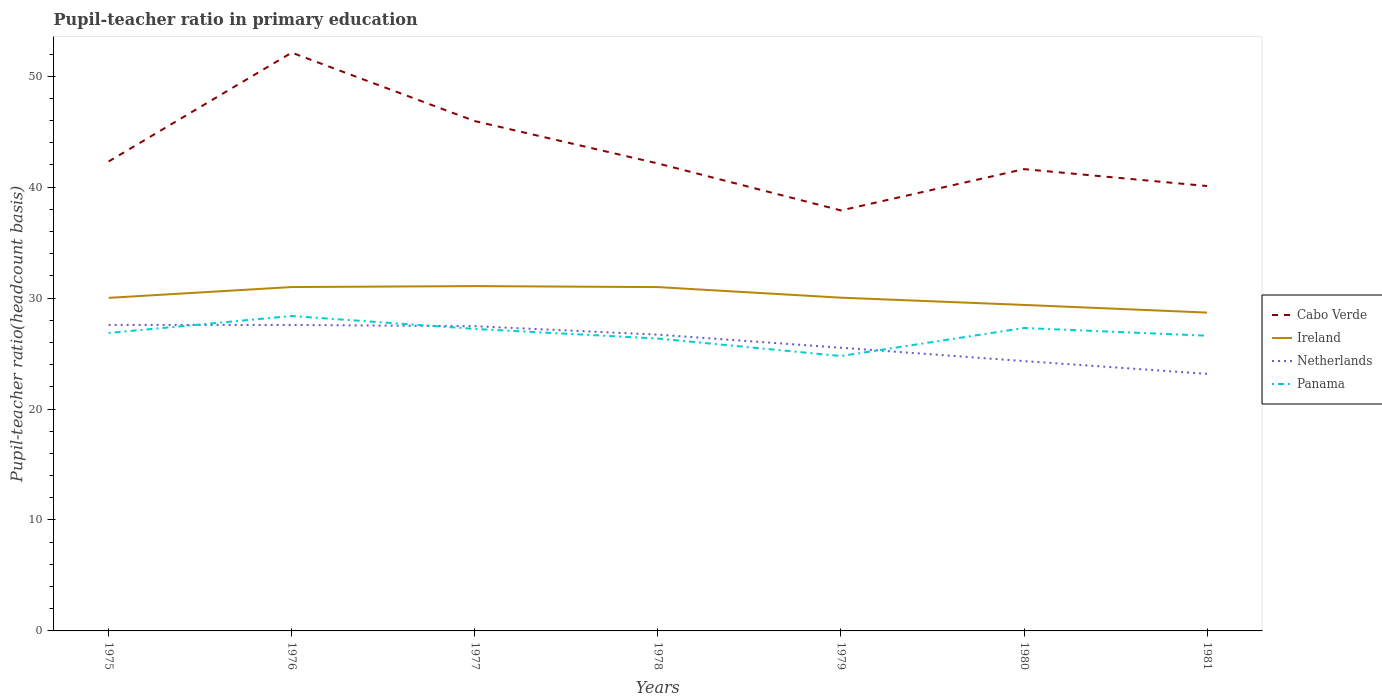Does the line corresponding to Ireland intersect with the line corresponding to Panama?
Keep it short and to the point. No. Across all years, what is the maximum pupil-teacher ratio in primary education in Netherlands?
Provide a short and direct response. 23.17. In which year was the pupil-teacher ratio in primary education in Ireland maximum?
Offer a terse response. 1981. What is the total pupil-teacher ratio in primary education in Ireland in the graph?
Make the answer very short. 0.95. What is the difference between the highest and the second highest pupil-teacher ratio in primary education in Cabo Verde?
Give a very brief answer. 14.22. What is the difference between the highest and the lowest pupil-teacher ratio in primary education in Ireland?
Provide a succinct answer. 3. Is the pupil-teacher ratio in primary education in Ireland strictly greater than the pupil-teacher ratio in primary education in Panama over the years?
Your answer should be very brief. No. How many lines are there?
Your answer should be very brief. 4. How many years are there in the graph?
Give a very brief answer. 7. What is the difference between two consecutive major ticks on the Y-axis?
Give a very brief answer. 10. Are the values on the major ticks of Y-axis written in scientific E-notation?
Provide a short and direct response. No. Does the graph contain grids?
Provide a short and direct response. No. Where does the legend appear in the graph?
Offer a very short reply. Center right. What is the title of the graph?
Provide a short and direct response. Pupil-teacher ratio in primary education. Does "Middle income" appear as one of the legend labels in the graph?
Your answer should be very brief. No. What is the label or title of the X-axis?
Offer a very short reply. Years. What is the label or title of the Y-axis?
Keep it short and to the point. Pupil-teacher ratio(headcount basis). What is the Pupil-teacher ratio(headcount basis) of Cabo Verde in 1975?
Ensure brevity in your answer.  42.31. What is the Pupil-teacher ratio(headcount basis) in Ireland in 1975?
Offer a very short reply. 30.02. What is the Pupil-teacher ratio(headcount basis) in Netherlands in 1975?
Your answer should be very brief. 27.58. What is the Pupil-teacher ratio(headcount basis) in Panama in 1975?
Your response must be concise. 26.86. What is the Pupil-teacher ratio(headcount basis) in Cabo Verde in 1976?
Your response must be concise. 52.13. What is the Pupil-teacher ratio(headcount basis) of Ireland in 1976?
Your answer should be very brief. 31. What is the Pupil-teacher ratio(headcount basis) in Netherlands in 1976?
Make the answer very short. 27.58. What is the Pupil-teacher ratio(headcount basis) in Panama in 1976?
Give a very brief answer. 28.39. What is the Pupil-teacher ratio(headcount basis) of Cabo Verde in 1977?
Give a very brief answer. 45.96. What is the Pupil-teacher ratio(headcount basis) in Ireland in 1977?
Offer a very short reply. 31.08. What is the Pupil-teacher ratio(headcount basis) of Netherlands in 1977?
Provide a short and direct response. 27.47. What is the Pupil-teacher ratio(headcount basis) in Panama in 1977?
Make the answer very short. 27.22. What is the Pupil-teacher ratio(headcount basis) in Cabo Verde in 1978?
Ensure brevity in your answer.  42.14. What is the Pupil-teacher ratio(headcount basis) in Ireland in 1978?
Ensure brevity in your answer.  30.99. What is the Pupil-teacher ratio(headcount basis) in Netherlands in 1978?
Give a very brief answer. 26.71. What is the Pupil-teacher ratio(headcount basis) in Panama in 1978?
Provide a short and direct response. 26.35. What is the Pupil-teacher ratio(headcount basis) in Cabo Verde in 1979?
Make the answer very short. 37.9. What is the Pupil-teacher ratio(headcount basis) of Ireland in 1979?
Keep it short and to the point. 30.04. What is the Pupil-teacher ratio(headcount basis) in Netherlands in 1979?
Your answer should be compact. 25.53. What is the Pupil-teacher ratio(headcount basis) of Panama in 1979?
Your answer should be compact. 24.78. What is the Pupil-teacher ratio(headcount basis) of Cabo Verde in 1980?
Make the answer very short. 41.63. What is the Pupil-teacher ratio(headcount basis) in Ireland in 1980?
Make the answer very short. 29.39. What is the Pupil-teacher ratio(headcount basis) in Netherlands in 1980?
Make the answer very short. 24.32. What is the Pupil-teacher ratio(headcount basis) in Panama in 1980?
Offer a terse response. 27.31. What is the Pupil-teacher ratio(headcount basis) in Cabo Verde in 1981?
Make the answer very short. 40.1. What is the Pupil-teacher ratio(headcount basis) in Ireland in 1981?
Ensure brevity in your answer.  28.7. What is the Pupil-teacher ratio(headcount basis) of Netherlands in 1981?
Give a very brief answer. 23.17. What is the Pupil-teacher ratio(headcount basis) of Panama in 1981?
Provide a succinct answer. 26.61. Across all years, what is the maximum Pupil-teacher ratio(headcount basis) of Cabo Verde?
Ensure brevity in your answer.  52.13. Across all years, what is the maximum Pupil-teacher ratio(headcount basis) of Ireland?
Your answer should be very brief. 31.08. Across all years, what is the maximum Pupil-teacher ratio(headcount basis) of Netherlands?
Your answer should be compact. 27.58. Across all years, what is the maximum Pupil-teacher ratio(headcount basis) in Panama?
Give a very brief answer. 28.39. Across all years, what is the minimum Pupil-teacher ratio(headcount basis) in Cabo Verde?
Provide a short and direct response. 37.9. Across all years, what is the minimum Pupil-teacher ratio(headcount basis) in Ireland?
Provide a succinct answer. 28.7. Across all years, what is the minimum Pupil-teacher ratio(headcount basis) of Netherlands?
Ensure brevity in your answer.  23.17. Across all years, what is the minimum Pupil-teacher ratio(headcount basis) in Panama?
Give a very brief answer. 24.78. What is the total Pupil-teacher ratio(headcount basis) in Cabo Verde in the graph?
Offer a terse response. 302.17. What is the total Pupil-teacher ratio(headcount basis) of Ireland in the graph?
Provide a short and direct response. 211.22. What is the total Pupil-teacher ratio(headcount basis) in Netherlands in the graph?
Offer a very short reply. 182.36. What is the total Pupil-teacher ratio(headcount basis) of Panama in the graph?
Your answer should be very brief. 187.52. What is the difference between the Pupil-teacher ratio(headcount basis) in Cabo Verde in 1975 and that in 1976?
Ensure brevity in your answer.  -9.81. What is the difference between the Pupil-teacher ratio(headcount basis) of Ireland in 1975 and that in 1976?
Your response must be concise. -0.97. What is the difference between the Pupil-teacher ratio(headcount basis) of Netherlands in 1975 and that in 1976?
Your response must be concise. 0. What is the difference between the Pupil-teacher ratio(headcount basis) of Panama in 1975 and that in 1976?
Provide a succinct answer. -1.53. What is the difference between the Pupil-teacher ratio(headcount basis) in Cabo Verde in 1975 and that in 1977?
Your response must be concise. -3.64. What is the difference between the Pupil-teacher ratio(headcount basis) in Ireland in 1975 and that in 1977?
Offer a terse response. -1.06. What is the difference between the Pupil-teacher ratio(headcount basis) of Netherlands in 1975 and that in 1977?
Your answer should be compact. 0.11. What is the difference between the Pupil-teacher ratio(headcount basis) in Panama in 1975 and that in 1977?
Offer a terse response. -0.36. What is the difference between the Pupil-teacher ratio(headcount basis) of Cabo Verde in 1975 and that in 1978?
Ensure brevity in your answer.  0.18. What is the difference between the Pupil-teacher ratio(headcount basis) in Ireland in 1975 and that in 1978?
Keep it short and to the point. -0.97. What is the difference between the Pupil-teacher ratio(headcount basis) in Netherlands in 1975 and that in 1978?
Offer a terse response. 0.88. What is the difference between the Pupil-teacher ratio(headcount basis) in Panama in 1975 and that in 1978?
Keep it short and to the point. 0.5. What is the difference between the Pupil-teacher ratio(headcount basis) in Cabo Verde in 1975 and that in 1979?
Provide a short and direct response. 4.41. What is the difference between the Pupil-teacher ratio(headcount basis) of Ireland in 1975 and that in 1979?
Offer a very short reply. -0.02. What is the difference between the Pupil-teacher ratio(headcount basis) in Netherlands in 1975 and that in 1979?
Offer a terse response. 2.05. What is the difference between the Pupil-teacher ratio(headcount basis) of Panama in 1975 and that in 1979?
Ensure brevity in your answer.  2.08. What is the difference between the Pupil-teacher ratio(headcount basis) of Cabo Verde in 1975 and that in 1980?
Ensure brevity in your answer.  0.69. What is the difference between the Pupil-teacher ratio(headcount basis) of Ireland in 1975 and that in 1980?
Give a very brief answer. 0.64. What is the difference between the Pupil-teacher ratio(headcount basis) of Netherlands in 1975 and that in 1980?
Your response must be concise. 3.26. What is the difference between the Pupil-teacher ratio(headcount basis) in Panama in 1975 and that in 1980?
Make the answer very short. -0.45. What is the difference between the Pupil-teacher ratio(headcount basis) in Cabo Verde in 1975 and that in 1981?
Offer a terse response. 2.21. What is the difference between the Pupil-teacher ratio(headcount basis) of Ireland in 1975 and that in 1981?
Your response must be concise. 1.33. What is the difference between the Pupil-teacher ratio(headcount basis) in Netherlands in 1975 and that in 1981?
Your answer should be very brief. 4.41. What is the difference between the Pupil-teacher ratio(headcount basis) of Panama in 1975 and that in 1981?
Keep it short and to the point. 0.25. What is the difference between the Pupil-teacher ratio(headcount basis) in Cabo Verde in 1976 and that in 1977?
Provide a succinct answer. 6.17. What is the difference between the Pupil-teacher ratio(headcount basis) in Ireland in 1976 and that in 1977?
Provide a short and direct response. -0.09. What is the difference between the Pupil-teacher ratio(headcount basis) of Netherlands in 1976 and that in 1977?
Ensure brevity in your answer.  0.11. What is the difference between the Pupil-teacher ratio(headcount basis) in Panama in 1976 and that in 1977?
Make the answer very short. 1.17. What is the difference between the Pupil-teacher ratio(headcount basis) of Cabo Verde in 1976 and that in 1978?
Your answer should be very brief. 9.99. What is the difference between the Pupil-teacher ratio(headcount basis) in Ireland in 1976 and that in 1978?
Make the answer very short. 0. What is the difference between the Pupil-teacher ratio(headcount basis) in Netherlands in 1976 and that in 1978?
Offer a terse response. 0.87. What is the difference between the Pupil-teacher ratio(headcount basis) in Panama in 1976 and that in 1978?
Ensure brevity in your answer.  2.03. What is the difference between the Pupil-teacher ratio(headcount basis) of Cabo Verde in 1976 and that in 1979?
Ensure brevity in your answer.  14.22. What is the difference between the Pupil-teacher ratio(headcount basis) in Ireland in 1976 and that in 1979?
Make the answer very short. 0.96. What is the difference between the Pupil-teacher ratio(headcount basis) of Netherlands in 1976 and that in 1979?
Keep it short and to the point. 2.05. What is the difference between the Pupil-teacher ratio(headcount basis) in Panama in 1976 and that in 1979?
Provide a succinct answer. 3.61. What is the difference between the Pupil-teacher ratio(headcount basis) of Cabo Verde in 1976 and that in 1980?
Provide a short and direct response. 10.5. What is the difference between the Pupil-teacher ratio(headcount basis) of Ireland in 1976 and that in 1980?
Your answer should be compact. 1.61. What is the difference between the Pupil-teacher ratio(headcount basis) of Netherlands in 1976 and that in 1980?
Your answer should be compact. 3.26. What is the difference between the Pupil-teacher ratio(headcount basis) of Panama in 1976 and that in 1980?
Your answer should be very brief. 1.08. What is the difference between the Pupil-teacher ratio(headcount basis) in Cabo Verde in 1976 and that in 1981?
Offer a terse response. 12.02. What is the difference between the Pupil-teacher ratio(headcount basis) in Ireland in 1976 and that in 1981?
Your response must be concise. 2.3. What is the difference between the Pupil-teacher ratio(headcount basis) of Netherlands in 1976 and that in 1981?
Provide a succinct answer. 4.41. What is the difference between the Pupil-teacher ratio(headcount basis) of Panama in 1976 and that in 1981?
Offer a terse response. 1.78. What is the difference between the Pupil-teacher ratio(headcount basis) of Cabo Verde in 1977 and that in 1978?
Offer a terse response. 3.82. What is the difference between the Pupil-teacher ratio(headcount basis) of Ireland in 1977 and that in 1978?
Provide a succinct answer. 0.09. What is the difference between the Pupil-teacher ratio(headcount basis) in Netherlands in 1977 and that in 1978?
Provide a short and direct response. 0.76. What is the difference between the Pupil-teacher ratio(headcount basis) in Panama in 1977 and that in 1978?
Provide a short and direct response. 0.87. What is the difference between the Pupil-teacher ratio(headcount basis) of Cabo Verde in 1977 and that in 1979?
Provide a succinct answer. 8.05. What is the difference between the Pupil-teacher ratio(headcount basis) in Ireland in 1977 and that in 1979?
Provide a succinct answer. 1.04. What is the difference between the Pupil-teacher ratio(headcount basis) of Netherlands in 1977 and that in 1979?
Keep it short and to the point. 1.94. What is the difference between the Pupil-teacher ratio(headcount basis) of Panama in 1977 and that in 1979?
Offer a terse response. 2.44. What is the difference between the Pupil-teacher ratio(headcount basis) of Cabo Verde in 1977 and that in 1980?
Provide a short and direct response. 4.33. What is the difference between the Pupil-teacher ratio(headcount basis) of Ireland in 1977 and that in 1980?
Make the answer very short. 1.7. What is the difference between the Pupil-teacher ratio(headcount basis) in Netherlands in 1977 and that in 1980?
Make the answer very short. 3.15. What is the difference between the Pupil-teacher ratio(headcount basis) of Panama in 1977 and that in 1980?
Keep it short and to the point. -0.08. What is the difference between the Pupil-teacher ratio(headcount basis) in Cabo Verde in 1977 and that in 1981?
Your answer should be compact. 5.85. What is the difference between the Pupil-teacher ratio(headcount basis) of Ireland in 1977 and that in 1981?
Your response must be concise. 2.39. What is the difference between the Pupil-teacher ratio(headcount basis) of Netherlands in 1977 and that in 1981?
Make the answer very short. 4.29. What is the difference between the Pupil-teacher ratio(headcount basis) in Panama in 1977 and that in 1981?
Offer a terse response. 0.61. What is the difference between the Pupil-teacher ratio(headcount basis) of Cabo Verde in 1978 and that in 1979?
Keep it short and to the point. 4.23. What is the difference between the Pupil-teacher ratio(headcount basis) in Ireland in 1978 and that in 1979?
Provide a short and direct response. 0.95. What is the difference between the Pupil-teacher ratio(headcount basis) in Netherlands in 1978 and that in 1979?
Your response must be concise. 1.18. What is the difference between the Pupil-teacher ratio(headcount basis) of Panama in 1978 and that in 1979?
Your answer should be compact. 1.58. What is the difference between the Pupil-teacher ratio(headcount basis) in Cabo Verde in 1978 and that in 1980?
Give a very brief answer. 0.51. What is the difference between the Pupil-teacher ratio(headcount basis) in Ireland in 1978 and that in 1980?
Offer a terse response. 1.61. What is the difference between the Pupil-teacher ratio(headcount basis) of Netherlands in 1978 and that in 1980?
Your answer should be compact. 2.38. What is the difference between the Pupil-teacher ratio(headcount basis) in Panama in 1978 and that in 1980?
Your response must be concise. -0.95. What is the difference between the Pupil-teacher ratio(headcount basis) in Cabo Verde in 1978 and that in 1981?
Give a very brief answer. 2.04. What is the difference between the Pupil-teacher ratio(headcount basis) in Ireland in 1978 and that in 1981?
Offer a very short reply. 2.3. What is the difference between the Pupil-teacher ratio(headcount basis) in Netherlands in 1978 and that in 1981?
Provide a succinct answer. 3.53. What is the difference between the Pupil-teacher ratio(headcount basis) of Panama in 1978 and that in 1981?
Provide a succinct answer. -0.26. What is the difference between the Pupil-teacher ratio(headcount basis) of Cabo Verde in 1979 and that in 1980?
Offer a terse response. -3.72. What is the difference between the Pupil-teacher ratio(headcount basis) in Ireland in 1979 and that in 1980?
Keep it short and to the point. 0.65. What is the difference between the Pupil-teacher ratio(headcount basis) of Netherlands in 1979 and that in 1980?
Ensure brevity in your answer.  1.2. What is the difference between the Pupil-teacher ratio(headcount basis) of Panama in 1979 and that in 1980?
Offer a terse response. -2.53. What is the difference between the Pupil-teacher ratio(headcount basis) in Cabo Verde in 1979 and that in 1981?
Provide a short and direct response. -2.2. What is the difference between the Pupil-teacher ratio(headcount basis) in Ireland in 1979 and that in 1981?
Offer a very short reply. 1.34. What is the difference between the Pupil-teacher ratio(headcount basis) of Netherlands in 1979 and that in 1981?
Your answer should be compact. 2.35. What is the difference between the Pupil-teacher ratio(headcount basis) in Panama in 1979 and that in 1981?
Your response must be concise. -1.83. What is the difference between the Pupil-teacher ratio(headcount basis) of Cabo Verde in 1980 and that in 1981?
Offer a terse response. 1.52. What is the difference between the Pupil-teacher ratio(headcount basis) of Ireland in 1980 and that in 1981?
Offer a very short reply. 0.69. What is the difference between the Pupil-teacher ratio(headcount basis) of Netherlands in 1980 and that in 1981?
Your answer should be very brief. 1.15. What is the difference between the Pupil-teacher ratio(headcount basis) in Panama in 1980 and that in 1981?
Your answer should be compact. 0.69. What is the difference between the Pupil-teacher ratio(headcount basis) in Cabo Verde in 1975 and the Pupil-teacher ratio(headcount basis) in Ireland in 1976?
Offer a terse response. 11.32. What is the difference between the Pupil-teacher ratio(headcount basis) in Cabo Verde in 1975 and the Pupil-teacher ratio(headcount basis) in Netherlands in 1976?
Keep it short and to the point. 14.73. What is the difference between the Pupil-teacher ratio(headcount basis) of Cabo Verde in 1975 and the Pupil-teacher ratio(headcount basis) of Panama in 1976?
Your answer should be very brief. 13.93. What is the difference between the Pupil-teacher ratio(headcount basis) in Ireland in 1975 and the Pupil-teacher ratio(headcount basis) in Netherlands in 1976?
Your response must be concise. 2.44. What is the difference between the Pupil-teacher ratio(headcount basis) of Ireland in 1975 and the Pupil-teacher ratio(headcount basis) of Panama in 1976?
Ensure brevity in your answer.  1.64. What is the difference between the Pupil-teacher ratio(headcount basis) in Netherlands in 1975 and the Pupil-teacher ratio(headcount basis) in Panama in 1976?
Provide a short and direct response. -0.8. What is the difference between the Pupil-teacher ratio(headcount basis) of Cabo Verde in 1975 and the Pupil-teacher ratio(headcount basis) of Ireland in 1977?
Offer a very short reply. 11.23. What is the difference between the Pupil-teacher ratio(headcount basis) of Cabo Verde in 1975 and the Pupil-teacher ratio(headcount basis) of Netherlands in 1977?
Make the answer very short. 14.85. What is the difference between the Pupil-teacher ratio(headcount basis) of Cabo Verde in 1975 and the Pupil-teacher ratio(headcount basis) of Panama in 1977?
Keep it short and to the point. 15.09. What is the difference between the Pupil-teacher ratio(headcount basis) in Ireland in 1975 and the Pupil-teacher ratio(headcount basis) in Netherlands in 1977?
Provide a succinct answer. 2.55. What is the difference between the Pupil-teacher ratio(headcount basis) of Ireland in 1975 and the Pupil-teacher ratio(headcount basis) of Panama in 1977?
Make the answer very short. 2.8. What is the difference between the Pupil-teacher ratio(headcount basis) of Netherlands in 1975 and the Pupil-teacher ratio(headcount basis) of Panama in 1977?
Provide a succinct answer. 0.36. What is the difference between the Pupil-teacher ratio(headcount basis) of Cabo Verde in 1975 and the Pupil-teacher ratio(headcount basis) of Ireland in 1978?
Your answer should be very brief. 11.32. What is the difference between the Pupil-teacher ratio(headcount basis) in Cabo Verde in 1975 and the Pupil-teacher ratio(headcount basis) in Netherlands in 1978?
Your response must be concise. 15.61. What is the difference between the Pupil-teacher ratio(headcount basis) of Cabo Verde in 1975 and the Pupil-teacher ratio(headcount basis) of Panama in 1978?
Make the answer very short. 15.96. What is the difference between the Pupil-teacher ratio(headcount basis) of Ireland in 1975 and the Pupil-teacher ratio(headcount basis) of Netherlands in 1978?
Your answer should be compact. 3.32. What is the difference between the Pupil-teacher ratio(headcount basis) of Ireland in 1975 and the Pupil-teacher ratio(headcount basis) of Panama in 1978?
Provide a succinct answer. 3.67. What is the difference between the Pupil-teacher ratio(headcount basis) of Netherlands in 1975 and the Pupil-teacher ratio(headcount basis) of Panama in 1978?
Provide a short and direct response. 1.23. What is the difference between the Pupil-teacher ratio(headcount basis) of Cabo Verde in 1975 and the Pupil-teacher ratio(headcount basis) of Ireland in 1979?
Your response must be concise. 12.28. What is the difference between the Pupil-teacher ratio(headcount basis) in Cabo Verde in 1975 and the Pupil-teacher ratio(headcount basis) in Netherlands in 1979?
Offer a very short reply. 16.79. What is the difference between the Pupil-teacher ratio(headcount basis) of Cabo Verde in 1975 and the Pupil-teacher ratio(headcount basis) of Panama in 1979?
Your response must be concise. 17.54. What is the difference between the Pupil-teacher ratio(headcount basis) in Ireland in 1975 and the Pupil-teacher ratio(headcount basis) in Netherlands in 1979?
Give a very brief answer. 4.5. What is the difference between the Pupil-teacher ratio(headcount basis) in Ireland in 1975 and the Pupil-teacher ratio(headcount basis) in Panama in 1979?
Ensure brevity in your answer.  5.24. What is the difference between the Pupil-teacher ratio(headcount basis) in Netherlands in 1975 and the Pupil-teacher ratio(headcount basis) in Panama in 1979?
Your answer should be compact. 2.8. What is the difference between the Pupil-teacher ratio(headcount basis) in Cabo Verde in 1975 and the Pupil-teacher ratio(headcount basis) in Ireland in 1980?
Give a very brief answer. 12.93. What is the difference between the Pupil-teacher ratio(headcount basis) in Cabo Verde in 1975 and the Pupil-teacher ratio(headcount basis) in Netherlands in 1980?
Ensure brevity in your answer.  17.99. What is the difference between the Pupil-teacher ratio(headcount basis) in Cabo Verde in 1975 and the Pupil-teacher ratio(headcount basis) in Panama in 1980?
Your response must be concise. 15.01. What is the difference between the Pupil-teacher ratio(headcount basis) of Ireland in 1975 and the Pupil-teacher ratio(headcount basis) of Netherlands in 1980?
Your answer should be very brief. 5.7. What is the difference between the Pupil-teacher ratio(headcount basis) of Ireland in 1975 and the Pupil-teacher ratio(headcount basis) of Panama in 1980?
Ensure brevity in your answer.  2.72. What is the difference between the Pupil-teacher ratio(headcount basis) in Netherlands in 1975 and the Pupil-teacher ratio(headcount basis) in Panama in 1980?
Your answer should be very brief. 0.28. What is the difference between the Pupil-teacher ratio(headcount basis) of Cabo Verde in 1975 and the Pupil-teacher ratio(headcount basis) of Ireland in 1981?
Offer a terse response. 13.62. What is the difference between the Pupil-teacher ratio(headcount basis) of Cabo Verde in 1975 and the Pupil-teacher ratio(headcount basis) of Netherlands in 1981?
Make the answer very short. 19.14. What is the difference between the Pupil-teacher ratio(headcount basis) of Cabo Verde in 1975 and the Pupil-teacher ratio(headcount basis) of Panama in 1981?
Your answer should be very brief. 15.7. What is the difference between the Pupil-teacher ratio(headcount basis) of Ireland in 1975 and the Pupil-teacher ratio(headcount basis) of Netherlands in 1981?
Your answer should be compact. 6.85. What is the difference between the Pupil-teacher ratio(headcount basis) in Ireland in 1975 and the Pupil-teacher ratio(headcount basis) in Panama in 1981?
Your answer should be compact. 3.41. What is the difference between the Pupil-teacher ratio(headcount basis) in Netherlands in 1975 and the Pupil-teacher ratio(headcount basis) in Panama in 1981?
Make the answer very short. 0.97. What is the difference between the Pupil-teacher ratio(headcount basis) in Cabo Verde in 1976 and the Pupil-teacher ratio(headcount basis) in Ireland in 1977?
Ensure brevity in your answer.  21.04. What is the difference between the Pupil-teacher ratio(headcount basis) in Cabo Verde in 1976 and the Pupil-teacher ratio(headcount basis) in Netherlands in 1977?
Keep it short and to the point. 24.66. What is the difference between the Pupil-teacher ratio(headcount basis) in Cabo Verde in 1976 and the Pupil-teacher ratio(headcount basis) in Panama in 1977?
Offer a very short reply. 24.91. What is the difference between the Pupil-teacher ratio(headcount basis) of Ireland in 1976 and the Pupil-teacher ratio(headcount basis) of Netherlands in 1977?
Offer a very short reply. 3.53. What is the difference between the Pupil-teacher ratio(headcount basis) in Ireland in 1976 and the Pupil-teacher ratio(headcount basis) in Panama in 1977?
Provide a short and direct response. 3.78. What is the difference between the Pupil-teacher ratio(headcount basis) in Netherlands in 1976 and the Pupil-teacher ratio(headcount basis) in Panama in 1977?
Give a very brief answer. 0.36. What is the difference between the Pupil-teacher ratio(headcount basis) of Cabo Verde in 1976 and the Pupil-teacher ratio(headcount basis) of Ireland in 1978?
Keep it short and to the point. 21.13. What is the difference between the Pupil-teacher ratio(headcount basis) of Cabo Verde in 1976 and the Pupil-teacher ratio(headcount basis) of Netherlands in 1978?
Make the answer very short. 25.42. What is the difference between the Pupil-teacher ratio(headcount basis) of Cabo Verde in 1976 and the Pupil-teacher ratio(headcount basis) of Panama in 1978?
Ensure brevity in your answer.  25.77. What is the difference between the Pupil-teacher ratio(headcount basis) in Ireland in 1976 and the Pupil-teacher ratio(headcount basis) in Netherlands in 1978?
Provide a short and direct response. 4.29. What is the difference between the Pupil-teacher ratio(headcount basis) in Ireland in 1976 and the Pupil-teacher ratio(headcount basis) in Panama in 1978?
Offer a very short reply. 4.64. What is the difference between the Pupil-teacher ratio(headcount basis) in Netherlands in 1976 and the Pupil-teacher ratio(headcount basis) in Panama in 1978?
Provide a short and direct response. 1.23. What is the difference between the Pupil-teacher ratio(headcount basis) in Cabo Verde in 1976 and the Pupil-teacher ratio(headcount basis) in Ireland in 1979?
Make the answer very short. 22.09. What is the difference between the Pupil-teacher ratio(headcount basis) in Cabo Verde in 1976 and the Pupil-teacher ratio(headcount basis) in Netherlands in 1979?
Your answer should be very brief. 26.6. What is the difference between the Pupil-teacher ratio(headcount basis) in Cabo Verde in 1976 and the Pupil-teacher ratio(headcount basis) in Panama in 1979?
Make the answer very short. 27.35. What is the difference between the Pupil-teacher ratio(headcount basis) in Ireland in 1976 and the Pupil-teacher ratio(headcount basis) in Netherlands in 1979?
Your answer should be very brief. 5.47. What is the difference between the Pupil-teacher ratio(headcount basis) of Ireland in 1976 and the Pupil-teacher ratio(headcount basis) of Panama in 1979?
Keep it short and to the point. 6.22. What is the difference between the Pupil-teacher ratio(headcount basis) in Netherlands in 1976 and the Pupil-teacher ratio(headcount basis) in Panama in 1979?
Your answer should be very brief. 2.8. What is the difference between the Pupil-teacher ratio(headcount basis) in Cabo Verde in 1976 and the Pupil-teacher ratio(headcount basis) in Ireland in 1980?
Provide a succinct answer. 22.74. What is the difference between the Pupil-teacher ratio(headcount basis) in Cabo Verde in 1976 and the Pupil-teacher ratio(headcount basis) in Netherlands in 1980?
Ensure brevity in your answer.  27.8. What is the difference between the Pupil-teacher ratio(headcount basis) of Cabo Verde in 1976 and the Pupil-teacher ratio(headcount basis) of Panama in 1980?
Provide a succinct answer. 24.82. What is the difference between the Pupil-teacher ratio(headcount basis) of Ireland in 1976 and the Pupil-teacher ratio(headcount basis) of Netherlands in 1980?
Keep it short and to the point. 6.67. What is the difference between the Pupil-teacher ratio(headcount basis) of Ireland in 1976 and the Pupil-teacher ratio(headcount basis) of Panama in 1980?
Give a very brief answer. 3.69. What is the difference between the Pupil-teacher ratio(headcount basis) of Netherlands in 1976 and the Pupil-teacher ratio(headcount basis) of Panama in 1980?
Give a very brief answer. 0.27. What is the difference between the Pupil-teacher ratio(headcount basis) of Cabo Verde in 1976 and the Pupil-teacher ratio(headcount basis) of Ireland in 1981?
Provide a short and direct response. 23.43. What is the difference between the Pupil-teacher ratio(headcount basis) in Cabo Verde in 1976 and the Pupil-teacher ratio(headcount basis) in Netherlands in 1981?
Provide a succinct answer. 28.95. What is the difference between the Pupil-teacher ratio(headcount basis) in Cabo Verde in 1976 and the Pupil-teacher ratio(headcount basis) in Panama in 1981?
Offer a terse response. 25.52. What is the difference between the Pupil-teacher ratio(headcount basis) of Ireland in 1976 and the Pupil-teacher ratio(headcount basis) of Netherlands in 1981?
Offer a terse response. 7.82. What is the difference between the Pupil-teacher ratio(headcount basis) in Ireland in 1976 and the Pupil-teacher ratio(headcount basis) in Panama in 1981?
Ensure brevity in your answer.  4.39. What is the difference between the Pupil-teacher ratio(headcount basis) in Netherlands in 1976 and the Pupil-teacher ratio(headcount basis) in Panama in 1981?
Provide a succinct answer. 0.97. What is the difference between the Pupil-teacher ratio(headcount basis) of Cabo Verde in 1977 and the Pupil-teacher ratio(headcount basis) of Ireland in 1978?
Provide a succinct answer. 14.96. What is the difference between the Pupil-teacher ratio(headcount basis) of Cabo Verde in 1977 and the Pupil-teacher ratio(headcount basis) of Netherlands in 1978?
Ensure brevity in your answer.  19.25. What is the difference between the Pupil-teacher ratio(headcount basis) of Cabo Verde in 1977 and the Pupil-teacher ratio(headcount basis) of Panama in 1978?
Offer a very short reply. 19.6. What is the difference between the Pupil-teacher ratio(headcount basis) of Ireland in 1977 and the Pupil-teacher ratio(headcount basis) of Netherlands in 1978?
Ensure brevity in your answer.  4.38. What is the difference between the Pupil-teacher ratio(headcount basis) of Ireland in 1977 and the Pupil-teacher ratio(headcount basis) of Panama in 1978?
Ensure brevity in your answer.  4.73. What is the difference between the Pupil-teacher ratio(headcount basis) in Netherlands in 1977 and the Pupil-teacher ratio(headcount basis) in Panama in 1978?
Give a very brief answer. 1.11. What is the difference between the Pupil-teacher ratio(headcount basis) in Cabo Verde in 1977 and the Pupil-teacher ratio(headcount basis) in Ireland in 1979?
Your answer should be very brief. 15.92. What is the difference between the Pupil-teacher ratio(headcount basis) of Cabo Verde in 1977 and the Pupil-teacher ratio(headcount basis) of Netherlands in 1979?
Ensure brevity in your answer.  20.43. What is the difference between the Pupil-teacher ratio(headcount basis) of Cabo Verde in 1977 and the Pupil-teacher ratio(headcount basis) of Panama in 1979?
Provide a succinct answer. 21.18. What is the difference between the Pupil-teacher ratio(headcount basis) of Ireland in 1977 and the Pupil-teacher ratio(headcount basis) of Netherlands in 1979?
Offer a very short reply. 5.55. What is the difference between the Pupil-teacher ratio(headcount basis) of Ireland in 1977 and the Pupil-teacher ratio(headcount basis) of Panama in 1979?
Provide a short and direct response. 6.3. What is the difference between the Pupil-teacher ratio(headcount basis) in Netherlands in 1977 and the Pupil-teacher ratio(headcount basis) in Panama in 1979?
Make the answer very short. 2.69. What is the difference between the Pupil-teacher ratio(headcount basis) of Cabo Verde in 1977 and the Pupil-teacher ratio(headcount basis) of Ireland in 1980?
Make the answer very short. 16.57. What is the difference between the Pupil-teacher ratio(headcount basis) of Cabo Verde in 1977 and the Pupil-teacher ratio(headcount basis) of Netherlands in 1980?
Provide a succinct answer. 21.63. What is the difference between the Pupil-teacher ratio(headcount basis) of Cabo Verde in 1977 and the Pupil-teacher ratio(headcount basis) of Panama in 1980?
Offer a terse response. 18.65. What is the difference between the Pupil-teacher ratio(headcount basis) of Ireland in 1977 and the Pupil-teacher ratio(headcount basis) of Netherlands in 1980?
Offer a very short reply. 6.76. What is the difference between the Pupil-teacher ratio(headcount basis) of Ireland in 1977 and the Pupil-teacher ratio(headcount basis) of Panama in 1980?
Offer a very short reply. 3.78. What is the difference between the Pupil-teacher ratio(headcount basis) of Netherlands in 1977 and the Pupil-teacher ratio(headcount basis) of Panama in 1980?
Ensure brevity in your answer.  0.16. What is the difference between the Pupil-teacher ratio(headcount basis) in Cabo Verde in 1977 and the Pupil-teacher ratio(headcount basis) in Ireland in 1981?
Provide a succinct answer. 17.26. What is the difference between the Pupil-teacher ratio(headcount basis) of Cabo Verde in 1977 and the Pupil-teacher ratio(headcount basis) of Netherlands in 1981?
Your answer should be very brief. 22.78. What is the difference between the Pupil-teacher ratio(headcount basis) of Cabo Verde in 1977 and the Pupil-teacher ratio(headcount basis) of Panama in 1981?
Provide a short and direct response. 19.35. What is the difference between the Pupil-teacher ratio(headcount basis) of Ireland in 1977 and the Pupil-teacher ratio(headcount basis) of Netherlands in 1981?
Ensure brevity in your answer.  7.91. What is the difference between the Pupil-teacher ratio(headcount basis) of Ireland in 1977 and the Pupil-teacher ratio(headcount basis) of Panama in 1981?
Offer a very short reply. 4.47. What is the difference between the Pupil-teacher ratio(headcount basis) of Netherlands in 1977 and the Pupil-teacher ratio(headcount basis) of Panama in 1981?
Your answer should be compact. 0.86. What is the difference between the Pupil-teacher ratio(headcount basis) in Cabo Verde in 1978 and the Pupil-teacher ratio(headcount basis) in Ireland in 1979?
Your answer should be compact. 12.1. What is the difference between the Pupil-teacher ratio(headcount basis) of Cabo Verde in 1978 and the Pupil-teacher ratio(headcount basis) of Netherlands in 1979?
Provide a short and direct response. 16.61. What is the difference between the Pupil-teacher ratio(headcount basis) in Cabo Verde in 1978 and the Pupil-teacher ratio(headcount basis) in Panama in 1979?
Provide a short and direct response. 17.36. What is the difference between the Pupil-teacher ratio(headcount basis) of Ireland in 1978 and the Pupil-teacher ratio(headcount basis) of Netherlands in 1979?
Offer a terse response. 5.46. What is the difference between the Pupil-teacher ratio(headcount basis) in Ireland in 1978 and the Pupil-teacher ratio(headcount basis) in Panama in 1979?
Your answer should be compact. 6.21. What is the difference between the Pupil-teacher ratio(headcount basis) in Netherlands in 1978 and the Pupil-teacher ratio(headcount basis) in Panama in 1979?
Your answer should be very brief. 1.93. What is the difference between the Pupil-teacher ratio(headcount basis) in Cabo Verde in 1978 and the Pupil-teacher ratio(headcount basis) in Ireland in 1980?
Ensure brevity in your answer.  12.75. What is the difference between the Pupil-teacher ratio(headcount basis) of Cabo Verde in 1978 and the Pupil-teacher ratio(headcount basis) of Netherlands in 1980?
Offer a very short reply. 17.81. What is the difference between the Pupil-teacher ratio(headcount basis) in Cabo Verde in 1978 and the Pupil-teacher ratio(headcount basis) in Panama in 1980?
Keep it short and to the point. 14.83. What is the difference between the Pupil-teacher ratio(headcount basis) in Ireland in 1978 and the Pupil-teacher ratio(headcount basis) in Netherlands in 1980?
Provide a short and direct response. 6.67. What is the difference between the Pupil-teacher ratio(headcount basis) in Ireland in 1978 and the Pupil-teacher ratio(headcount basis) in Panama in 1980?
Your response must be concise. 3.69. What is the difference between the Pupil-teacher ratio(headcount basis) of Netherlands in 1978 and the Pupil-teacher ratio(headcount basis) of Panama in 1980?
Ensure brevity in your answer.  -0.6. What is the difference between the Pupil-teacher ratio(headcount basis) of Cabo Verde in 1978 and the Pupil-teacher ratio(headcount basis) of Ireland in 1981?
Provide a succinct answer. 13.44. What is the difference between the Pupil-teacher ratio(headcount basis) in Cabo Verde in 1978 and the Pupil-teacher ratio(headcount basis) in Netherlands in 1981?
Keep it short and to the point. 18.96. What is the difference between the Pupil-teacher ratio(headcount basis) of Cabo Verde in 1978 and the Pupil-teacher ratio(headcount basis) of Panama in 1981?
Make the answer very short. 15.53. What is the difference between the Pupil-teacher ratio(headcount basis) in Ireland in 1978 and the Pupil-teacher ratio(headcount basis) in Netherlands in 1981?
Provide a succinct answer. 7.82. What is the difference between the Pupil-teacher ratio(headcount basis) of Ireland in 1978 and the Pupil-teacher ratio(headcount basis) of Panama in 1981?
Keep it short and to the point. 4.38. What is the difference between the Pupil-teacher ratio(headcount basis) of Netherlands in 1978 and the Pupil-teacher ratio(headcount basis) of Panama in 1981?
Offer a very short reply. 0.1. What is the difference between the Pupil-teacher ratio(headcount basis) in Cabo Verde in 1979 and the Pupil-teacher ratio(headcount basis) in Ireland in 1980?
Make the answer very short. 8.52. What is the difference between the Pupil-teacher ratio(headcount basis) in Cabo Verde in 1979 and the Pupil-teacher ratio(headcount basis) in Netherlands in 1980?
Ensure brevity in your answer.  13.58. What is the difference between the Pupil-teacher ratio(headcount basis) in Cabo Verde in 1979 and the Pupil-teacher ratio(headcount basis) in Panama in 1980?
Provide a short and direct response. 10.6. What is the difference between the Pupil-teacher ratio(headcount basis) of Ireland in 1979 and the Pupil-teacher ratio(headcount basis) of Netherlands in 1980?
Ensure brevity in your answer.  5.72. What is the difference between the Pupil-teacher ratio(headcount basis) in Ireland in 1979 and the Pupil-teacher ratio(headcount basis) in Panama in 1980?
Keep it short and to the point. 2.73. What is the difference between the Pupil-teacher ratio(headcount basis) of Netherlands in 1979 and the Pupil-teacher ratio(headcount basis) of Panama in 1980?
Provide a succinct answer. -1.78. What is the difference between the Pupil-teacher ratio(headcount basis) of Cabo Verde in 1979 and the Pupil-teacher ratio(headcount basis) of Ireland in 1981?
Your response must be concise. 9.21. What is the difference between the Pupil-teacher ratio(headcount basis) in Cabo Verde in 1979 and the Pupil-teacher ratio(headcount basis) in Netherlands in 1981?
Give a very brief answer. 14.73. What is the difference between the Pupil-teacher ratio(headcount basis) in Cabo Verde in 1979 and the Pupil-teacher ratio(headcount basis) in Panama in 1981?
Your response must be concise. 11.29. What is the difference between the Pupil-teacher ratio(headcount basis) in Ireland in 1979 and the Pupil-teacher ratio(headcount basis) in Netherlands in 1981?
Make the answer very short. 6.86. What is the difference between the Pupil-teacher ratio(headcount basis) in Ireland in 1979 and the Pupil-teacher ratio(headcount basis) in Panama in 1981?
Your answer should be very brief. 3.43. What is the difference between the Pupil-teacher ratio(headcount basis) in Netherlands in 1979 and the Pupil-teacher ratio(headcount basis) in Panama in 1981?
Your answer should be very brief. -1.08. What is the difference between the Pupil-teacher ratio(headcount basis) of Cabo Verde in 1980 and the Pupil-teacher ratio(headcount basis) of Ireland in 1981?
Your answer should be very brief. 12.93. What is the difference between the Pupil-teacher ratio(headcount basis) of Cabo Verde in 1980 and the Pupil-teacher ratio(headcount basis) of Netherlands in 1981?
Provide a succinct answer. 18.45. What is the difference between the Pupil-teacher ratio(headcount basis) in Cabo Verde in 1980 and the Pupil-teacher ratio(headcount basis) in Panama in 1981?
Offer a terse response. 15.02. What is the difference between the Pupil-teacher ratio(headcount basis) of Ireland in 1980 and the Pupil-teacher ratio(headcount basis) of Netherlands in 1981?
Provide a short and direct response. 6.21. What is the difference between the Pupil-teacher ratio(headcount basis) in Ireland in 1980 and the Pupil-teacher ratio(headcount basis) in Panama in 1981?
Ensure brevity in your answer.  2.78. What is the difference between the Pupil-teacher ratio(headcount basis) in Netherlands in 1980 and the Pupil-teacher ratio(headcount basis) in Panama in 1981?
Provide a succinct answer. -2.29. What is the average Pupil-teacher ratio(headcount basis) of Cabo Verde per year?
Provide a succinct answer. 43.17. What is the average Pupil-teacher ratio(headcount basis) of Ireland per year?
Provide a short and direct response. 30.17. What is the average Pupil-teacher ratio(headcount basis) of Netherlands per year?
Ensure brevity in your answer.  26.05. What is the average Pupil-teacher ratio(headcount basis) of Panama per year?
Your answer should be very brief. 26.79. In the year 1975, what is the difference between the Pupil-teacher ratio(headcount basis) of Cabo Verde and Pupil-teacher ratio(headcount basis) of Ireland?
Your answer should be compact. 12.29. In the year 1975, what is the difference between the Pupil-teacher ratio(headcount basis) in Cabo Verde and Pupil-teacher ratio(headcount basis) in Netherlands?
Offer a terse response. 14.73. In the year 1975, what is the difference between the Pupil-teacher ratio(headcount basis) in Cabo Verde and Pupil-teacher ratio(headcount basis) in Panama?
Your response must be concise. 15.46. In the year 1975, what is the difference between the Pupil-teacher ratio(headcount basis) of Ireland and Pupil-teacher ratio(headcount basis) of Netherlands?
Offer a terse response. 2.44. In the year 1975, what is the difference between the Pupil-teacher ratio(headcount basis) of Ireland and Pupil-teacher ratio(headcount basis) of Panama?
Your response must be concise. 3.17. In the year 1975, what is the difference between the Pupil-teacher ratio(headcount basis) of Netherlands and Pupil-teacher ratio(headcount basis) of Panama?
Ensure brevity in your answer.  0.73. In the year 1976, what is the difference between the Pupil-teacher ratio(headcount basis) in Cabo Verde and Pupil-teacher ratio(headcount basis) in Ireland?
Your response must be concise. 21.13. In the year 1976, what is the difference between the Pupil-teacher ratio(headcount basis) of Cabo Verde and Pupil-teacher ratio(headcount basis) of Netherlands?
Offer a terse response. 24.55. In the year 1976, what is the difference between the Pupil-teacher ratio(headcount basis) in Cabo Verde and Pupil-teacher ratio(headcount basis) in Panama?
Provide a short and direct response. 23.74. In the year 1976, what is the difference between the Pupil-teacher ratio(headcount basis) of Ireland and Pupil-teacher ratio(headcount basis) of Netherlands?
Keep it short and to the point. 3.42. In the year 1976, what is the difference between the Pupil-teacher ratio(headcount basis) in Ireland and Pupil-teacher ratio(headcount basis) in Panama?
Ensure brevity in your answer.  2.61. In the year 1976, what is the difference between the Pupil-teacher ratio(headcount basis) in Netherlands and Pupil-teacher ratio(headcount basis) in Panama?
Your answer should be very brief. -0.81. In the year 1977, what is the difference between the Pupil-teacher ratio(headcount basis) of Cabo Verde and Pupil-teacher ratio(headcount basis) of Ireland?
Your answer should be very brief. 14.87. In the year 1977, what is the difference between the Pupil-teacher ratio(headcount basis) of Cabo Verde and Pupil-teacher ratio(headcount basis) of Netherlands?
Provide a short and direct response. 18.49. In the year 1977, what is the difference between the Pupil-teacher ratio(headcount basis) of Cabo Verde and Pupil-teacher ratio(headcount basis) of Panama?
Ensure brevity in your answer.  18.73. In the year 1977, what is the difference between the Pupil-teacher ratio(headcount basis) in Ireland and Pupil-teacher ratio(headcount basis) in Netherlands?
Offer a terse response. 3.61. In the year 1977, what is the difference between the Pupil-teacher ratio(headcount basis) in Ireland and Pupil-teacher ratio(headcount basis) in Panama?
Keep it short and to the point. 3.86. In the year 1977, what is the difference between the Pupil-teacher ratio(headcount basis) in Netherlands and Pupil-teacher ratio(headcount basis) in Panama?
Keep it short and to the point. 0.25. In the year 1978, what is the difference between the Pupil-teacher ratio(headcount basis) of Cabo Verde and Pupil-teacher ratio(headcount basis) of Ireland?
Your answer should be compact. 11.14. In the year 1978, what is the difference between the Pupil-teacher ratio(headcount basis) in Cabo Verde and Pupil-teacher ratio(headcount basis) in Netherlands?
Ensure brevity in your answer.  15.43. In the year 1978, what is the difference between the Pupil-teacher ratio(headcount basis) of Cabo Verde and Pupil-teacher ratio(headcount basis) of Panama?
Your response must be concise. 15.78. In the year 1978, what is the difference between the Pupil-teacher ratio(headcount basis) in Ireland and Pupil-teacher ratio(headcount basis) in Netherlands?
Make the answer very short. 4.29. In the year 1978, what is the difference between the Pupil-teacher ratio(headcount basis) in Ireland and Pupil-teacher ratio(headcount basis) in Panama?
Offer a very short reply. 4.64. In the year 1978, what is the difference between the Pupil-teacher ratio(headcount basis) in Netherlands and Pupil-teacher ratio(headcount basis) in Panama?
Offer a very short reply. 0.35. In the year 1979, what is the difference between the Pupil-teacher ratio(headcount basis) of Cabo Verde and Pupil-teacher ratio(headcount basis) of Ireland?
Make the answer very short. 7.86. In the year 1979, what is the difference between the Pupil-teacher ratio(headcount basis) of Cabo Verde and Pupil-teacher ratio(headcount basis) of Netherlands?
Your answer should be very brief. 12.37. In the year 1979, what is the difference between the Pupil-teacher ratio(headcount basis) of Cabo Verde and Pupil-teacher ratio(headcount basis) of Panama?
Your answer should be compact. 13.12. In the year 1979, what is the difference between the Pupil-teacher ratio(headcount basis) of Ireland and Pupil-teacher ratio(headcount basis) of Netherlands?
Your answer should be very brief. 4.51. In the year 1979, what is the difference between the Pupil-teacher ratio(headcount basis) of Ireland and Pupil-teacher ratio(headcount basis) of Panama?
Give a very brief answer. 5.26. In the year 1979, what is the difference between the Pupil-teacher ratio(headcount basis) in Netherlands and Pupil-teacher ratio(headcount basis) in Panama?
Provide a succinct answer. 0.75. In the year 1980, what is the difference between the Pupil-teacher ratio(headcount basis) in Cabo Verde and Pupil-teacher ratio(headcount basis) in Ireland?
Ensure brevity in your answer.  12.24. In the year 1980, what is the difference between the Pupil-teacher ratio(headcount basis) in Cabo Verde and Pupil-teacher ratio(headcount basis) in Netherlands?
Give a very brief answer. 17.3. In the year 1980, what is the difference between the Pupil-teacher ratio(headcount basis) in Cabo Verde and Pupil-teacher ratio(headcount basis) in Panama?
Keep it short and to the point. 14.32. In the year 1980, what is the difference between the Pupil-teacher ratio(headcount basis) in Ireland and Pupil-teacher ratio(headcount basis) in Netherlands?
Your answer should be very brief. 5.06. In the year 1980, what is the difference between the Pupil-teacher ratio(headcount basis) in Ireland and Pupil-teacher ratio(headcount basis) in Panama?
Ensure brevity in your answer.  2.08. In the year 1980, what is the difference between the Pupil-teacher ratio(headcount basis) in Netherlands and Pupil-teacher ratio(headcount basis) in Panama?
Offer a very short reply. -2.98. In the year 1981, what is the difference between the Pupil-teacher ratio(headcount basis) in Cabo Verde and Pupil-teacher ratio(headcount basis) in Ireland?
Offer a very short reply. 11.41. In the year 1981, what is the difference between the Pupil-teacher ratio(headcount basis) in Cabo Verde and Pupil-teacher ratio(headcount basis) in Netherlands?
Ensure brevity in your answer.  16.93. In the year 1981, what is the difference between the Pupil-teacher ratio(headcount basis) in Cabo Verde and Pupil-teacher ratio(headcount basis) in Panama?
Provide a short and direct response. 13.49. In the year 1981, what is the difference between the Pupil-teacher ratio(headcount basis) in Ireland and Pupil-teacher ratio(headcount basis) in Netherlands?
Provide a short and direct response. 5.52. In the year 1981, what is the difference between the Pupil-teacher ratio(headcount basis) in Ireland and Pupil-teacher ratio(headcount basis) in Panama?
Offer a terse response. 2.09. In the year 1981, what is the difference between the Pupil-teacher ratio(headcount basis) of Netherlands and Pupil-teacher ratio(headcount basis) of Panama?
Provide a short and direct response. -3.44. What is the ratio of the Pupil-teacher ratio(headcount basis) of Cabo Verde in 1975 to that in 1976?
Keep it short and to the point. 0.81. What is the ratio of the Pupil-teacher ratio(headcount basis) in Ireland in 1975 to that in 1976?
Offer a terse response. 0.97. What is the ratio of the Pupil-teacher ratio(headcount basis) of Netherlands in 1975 to that in 1976?
Give a very brief answer. 1. What is the ratio of the Pupil-teacher ratio(headcount basis) of Panama in 1975 to that in 1976?
Your response must be concise. 0.95. What is the ratio of the Pupil-teacher ratio(headcount basis) in Cabo Verde in 1975 to that in 1977?
Your answer should be very brief. 0.92. What is the ratio of the Pupil-teacher ratio(headcount basis) in Ireland in 1975 to that in 1977?
Give a very brief answer. 0.97. What is the ratio of the Pupil-teacher ratio(headcount basis) in Panama in 1975 to that in 1977?
Provide a short and direct response. 0.99. What is the ratio of the Pupil-teacher ratio(headcount basis) of Ireland in 1975 to that in 1978?
Keep it short and to the point. 0.97. What is the ratio of the Pupil-teacher ratio(headcount basis) of Netherlands in 1975 to that in 1978?
Your answer should be compact. 1.03. What is the ratio of the Pupil-teacher ratio(headcount basis) in Panama in 1975 to that in 1978?
Your response must be concise. 1.02. What is the ratio of the Pupil-teacher ratio(headcount basis) in Cabo Verde in 1975 to that in 1979?
Make the answer very short. 1.12. What is the ratio of the Pupil-teacher ratio(headcount basis) of Netherlands in 1975 to that in 1979?
Provide a succinct answer. 1.08. What is the ratio of the Pupil-teacher ratio(headcount basis) of Panama in 1975 to that in 1979?
Your answer should be very brief. 1.08. What is the ratio of the Pupil-teacher ratio(headcount basis) in Cabo Verde in 1975 to that in 1980?
Offer a terse response. 1.02. What is the ratio of the Pupil-teacher ratio(headcount basis) in Ireland in 1975 to that in 1980?
Provide a succinct answer. 1.02. What is the ratio of the Pupil-teacher ratio(headcount basis) of Netherlands in 1975 to that in 1980?
Provide a short and direct response. 1.13. What is the ratio of the Pupil-teacher ratio(headcount basis) of Panama in 1975 to that in 1980?
Ensure brevity in your answer.  0.98. What is the ratio of the Pupil-teacher ratio(headcount basis) in Cabo Verde in 1975 to that in 1981?
Offer a terse response. 1.06. What is the ratio of the Pupil-teacher ratio(headcount basis) of Ireland in 1975 to that in 1981?
Provide a short and direct response. 1.05. What is the ratio of the Pupil-teacher ratio(headcount basis) in Netherlands in 1975 to that in 1981?
Offer a terse response. 1.19. What is the ratio of the Pupil-teacher ratio(headcount basis) of Panama in 1975 to that in 1981?
Your response must be concise. 1.01. What is the ratio of the Pupil-teacher ratio(headcount basis) of Cabo Verde in 1976 to that in 1977?
Offer a very short reply. 1.13. What is the ratio of the Pupil-teacher ratio(headcount basis) in Panama in 1976 to that in 1977?
Your answer should be very brief. 1.04. What is the ratio of the Pupil-teacher ratio(headcount basis) in Cabo Verde in 1976 to that in 1978?
Your answer should be very brief. 1.24. What is the ratio of the Pupil-teacher ratio(headcount basis) of Ireland in 1976 to that in 1978?
Ensure brevity in your answer.  1. What is the ratio of the Pupil-teacher ratio(headcount basis) in Netherlands in 1976 to that in 1978?
Offer a terse response. 1.03. What is the ratio of the Pupil-teacher ratio(headcount basis) of Panama in 1976 to that in 1978?
Offer a very short reply. 1.08. What is the ratio of the Pupil-teacher ratio(headcount basis) in Cabo Verde in 1976 to that in 1979?
Keep it short and to the point. 1.38. What is the ratio of the Pupil-teacher ratio(headcount basis) in Ireland in 1976 to that in 1979?
Provide a succinct answer. 1.03. What is the ratio of the Pupil-teacher ratio(headcount basis) of Netherlands in 1976 to that in 1979?
Your answer should be very brief. 1.08. What is the ratio of the Pupil-teacher ratio(headcount basis) in Panama in 1976 to that in 1979?
Offer a terse response. 1.15. What is the ratio of the Pupil-teacher ratio(headcount basis) in Cabo Verde in 1976 to that in 1980?
Keep it short and to the point. 1.25. What is the ratio of the Pupil-teacher ratio(headcount basis) of Ireland in 1976 to that in 1980?
Your answer should be compact. 1.05. What is the ratio of the Pupil-teacher ratio(headcount basis) in Netherlands in 1976 to that in 1980?
Offer a very short reply. 1.13. What is the ratio of the Pupil-teacher ratio(headcount basis) in Panama in 1976 to that in 1980?
Give a very brief answer. 1.04. What is the ratio of the Pupil-teacher ratio(headcount basis) of Cabo Verde in 1976 to that in 1981?
Your response must be concise. 1.3. What is the ratio of the Pupil-teacher ratio(headcount basis) in Ireland in 1976 to that in 1981?
Your answer should be compact. 1.08. What is the ratio of the Pupil-teacher ratio(headcount basis) of Netherlands in 1976 to that in 1981?
Ensure brevity in your answer.  1.19. What is the ratio of the Pupil-teacher ratio(headcount basis) of Panama in 1976 to that in 1981?
Your response must be concise. 1.07. What is the ratio of the Pupil-teacher ratio(headcount basis) of Cabo Verde in 1977 to that in 1978?
Offer a terse response. 1.09. What is the ratio of the Pupil-teacher ratio(headcount basis) of Netherlands in 1977 to that in 1978?
Give a very brief answer. 1.03. What is the ratio of the Pupil-teacher ratio(headcount basis) in Panama in 1977 to that in 1978?
Ensure brevity in your answer.  1.03. What is the ratio of the Pupil-teacher ratio(headcount basis) in Cabo Verde in 1977 to that in 1979?
Make the answer very short. 1.21. What is the ratio of the Pupil-teacher ratio(headcount basis) in Ireland in 1977 to that in 1979?
Your response must be concise. 1.03. What is the ratio of the Pupil-teacher ratio(headcount basis) of Netherlands in 1977 to that in 1979?
Keep it short and to the point. 1.08. What is the ratio of the Pupil-teacher ratio(headcount basis) in Panama in 1977 to that in 1979?
Make the answer very short. 1.1. What is the ratio of the Pupil-teacher ratio(headcount basis) in Cabo Verde in 1977 to that in 1980?
Provide a short and direct response. 1.1. What is the ratio of the Pupil-teacher ratio(headcount basis) in Ireland in 1977 to that in 1980?
Your answer should be very brief. 1.06. What is the ratio of the Pupil-teacher ratio(headcount basis) of Netherlands in 1977 to that in 1980?
Make the answer very short. 1.13. What is the ratio of the Pupil-teacher ratio(headcount basis) in Cabo Verde in 1977 to that in 1981?
Your answer should be compact. 1.15. What is the ratio of the Pupil-teacher ratio(headcount basis) in Ireland in 1977 to that in 1981?
Give a very brief answer. 1.08. What is the ratio of the Pupil-teacher ratio(headcount basis) of Netherlands in 1977 to that in 1981?
Provide a short and direct response. 1.19. What is the ratio of the Pupil-teacher ratio(headcount basis) of Panama in 1977 to that in 1981?
Your response must be concise. 1.02. What is the ratio of the Pupil-teacher ratio(headcount basis) in Cabo Verde in 1978 to that in 1979?
Offer a terse response. 1.11. What is the ratio of the Pupil-teacher ratio(headcount basis) of Ireland in 1978 to that in 1979?
Your answer should be very brief. 1.03. What is the ratio of the Pupil-teacher ratio(headcount basis) of Netherlands in 1978 to that in 1979?
Your answer should be very brief. 1.05. What is the ratio of the Pupil-teacher ratio(headcount basis) in Panama in 1978 to that in 1979?
Your response must be concise. 1.06. What is the ratio of the Pupil-teacher ratio(headcount basis) in Cabo Verde in 1978 to that in 1980?
Make the answer very short. 1.01. What is the ratio of the Pupil-teacher ratio(headcount basis) in Ireland in 1978 to that in 1980?
Your answer should be compact. 1.05. What is the ratio of the Pupil-teacher ratio(headcount basis) in Netherlands in 1978 to that in 1980?
Give a very brief answer. 1.1. What is the ratio of the Pupil-teacher ratio(headcount basis) of Panama in 1978 to that in 1980?
Ensure brevity in your answer.  0.97. What is the ratio of the Pupil-teacher ratio(headcount basis) in Cabo Verde in 1978 to that in 1981?
Provide a succinct answer. 1.05. What is the ratio of the Pupil-teacher ratio(headcount basis) in Ireland in 1978 to that in 1981?
Ensure brevity in your answer.  1.08. What is the ratio of the Pupil-teacher ratio(headcount basis) of Netherlands in 1978 to that in 1981?
Make the answer very short. 1.15. What is the ratio of the Pupil-teacher ratio(headcount basis) in Cabo Verde in 1979 to that in 1980?
Provide a short and direct response. 0.91. What is the ratio of the Pupil-teacher ratio(headcount basis) in Ireland in 1979 to that in 1980?
Provide a short and direct response. 1.02. What is the ratio of the Pupil-teacher ratio(headcount basis) of Netherlands in 1979 to that in 1980?
Provide a short and direct response. 1.05. What is the ratio of the Pupil-teacher ratio(headcount basis) of Panama in 1979 to that in 1980?
Provide a short and direct response. 0.91. What is the ratio of the Pupil-teacher ratio(headcount basis) in Cabo Verde in 1979 to that in 1981?
Make the answer very short. 0.95. What is the ratio of the Pupil-teacher ratio(headcount basis) in Ireland in 1979 to that in 1981?
Offer a terse response. 1.05. What is the ratio of the Pupil-teacher ratio(headcount basis) of Netherlands in 1979 to that in 1981?
Ensure brevity in your answer.  1.1. What is the ratio of the Pupil-teacher ratio(headcount basis) of Panama in 1979 to that in 1981?
Your answer should be very brief. 0.93. What is the ratio of the Pupil-teacher ratio(headcount basis) in Cabo Verde in 1980 to that in 1981?
Provide a succinct answer. 1.04. What is the ratio of the Pupil-teacher ratio(headcount basis) in Netherlands in 1980 to that in 1981?
Offer a terse response. 1.05. What is the ratio of the Pupil-teacher ratio(headcount basis) of Panama in 1980 to that in 1981?
Make the answer very short. 1.03. What is the difference between the highest and the second highest Pupil-teacher ratio(headcount basis) in Cabo Verde?
Provide a succinct answer. 6.17. What is the difference between the highest and the second highest Pupil-teacher ratio(headcount basis) of Ireland?
Provide a succinct answer. 0.09. What is the difference between the highest and the second highest Pupil-teacher ratio(headcount basis) of Netherlands?
Ensure brevity in your answer.  0. What is the difference between the highest and the second highest Pupil-teacher ratio(headcount basis) in Panama?
Provide a short and direct response. 1.08. What is the difference between the highest and the lowest Pupil-teacher ratio(headcount basis) in Cabo Verde?
Ensure brevity in your answer.  14.22. What is the difference between the highest and the lowest Pupil-teacher ratio(headcount basis) of Ireland?
Provide a succinct answer. 2.39. What is the difference between the highest and the lowest Pupil-teacher ratio(headcount basis) in Netherlands?
Your answer should be compact. 4.41. What is the difference between the highest and the lowest Pupil-teacher ratio(headcount basis) in Panama?
Keep it short and to the point. 3.61. 